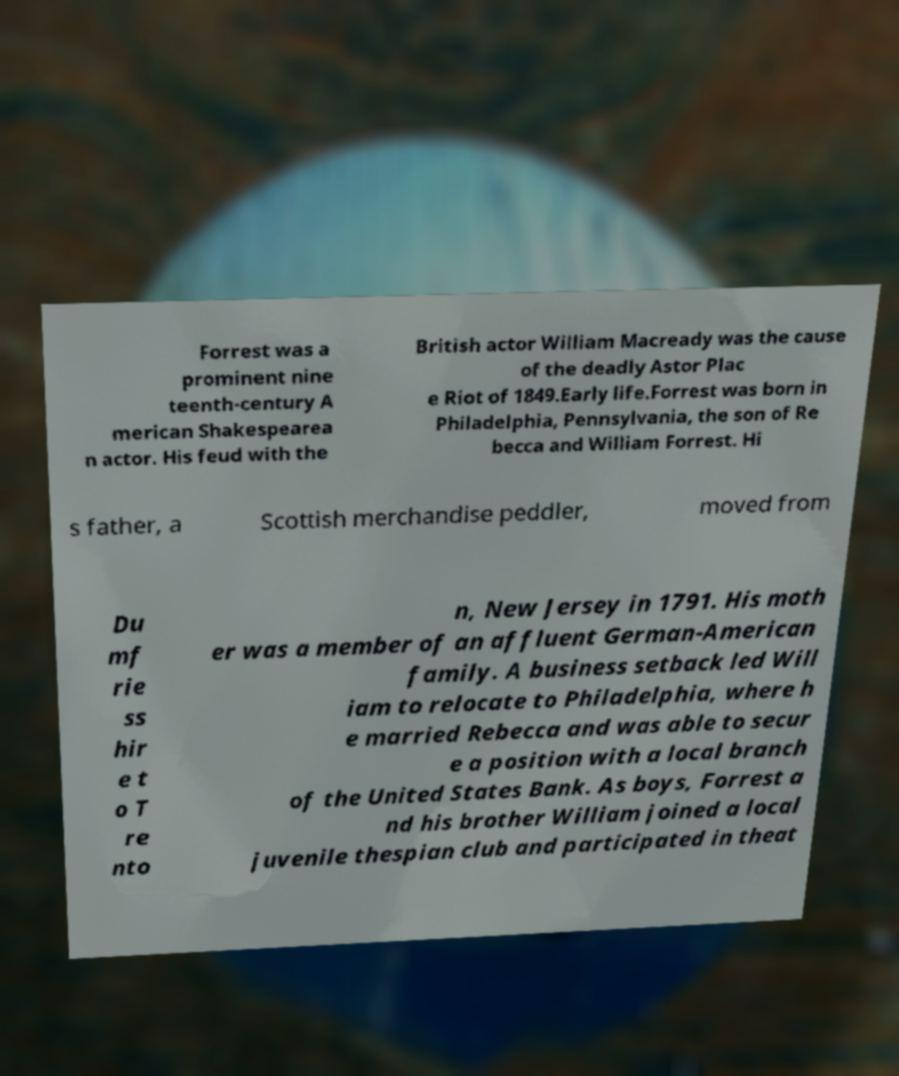Could you extract and type out the text from this image? Forrest was a prominent nine teenth-century A merican Shakespearea n actor. His feud with the British actor William Macready was the cause of the deadly Astor Plac e Riot of 1849.Early life.Forrest was born in Philadelphia, Pennsylvania, the son of Re becca and William Forrest. Hi s father, a Scottish merchandise peddler, moved from Du mf rie ss hir e t o T re nto n, New Jersey in 1791. His moth er was a member of an affluent German-American family. A business setback led Will iam to relocate to Philadelphia, where h e married Rebecca and was able to secur e a position with a local branch of the United States Bank. As boys, Forrest a nd his brother William joined a local juvenile thespian club and participated in theat 